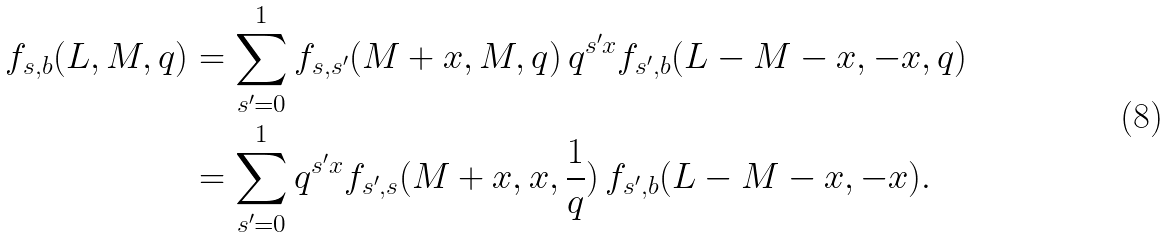<formula> <loc_0><loc_0><loc_500><loc_500>f _ { s , b } ( L , M , q ) & = \sum _ { s ^ { \prime } = 0 } ^ { 1 } f _ { s , s ^ { \prime } } ( M + x , M , q ) \, q ^ { s ^ { \prime } x } f _ { s ^ { \prime } , b } ( L - M - x , - x , q ) \\ & = \sum _ { s ^ { \prime } = 0 } ^ { 1 } q ^ { s ^ { \prime } x } f _ { s ^ { \prime } , s } ( M + x , x , \frac { 1 } { q } ) \, f _ { s ^ { \prime } , b } ( L - M - x , - x ) .</formula> 